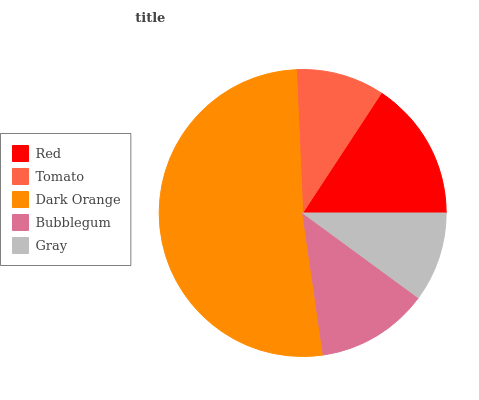Is Tomato the minimum?
Answer yes or no. Yes. Is Dark Orange the maximum?
Answer yes or no. Yes. Is Dark Orange the minimum?
Answer yes or no. No. Is Tomato the maximum?
Answer yes or no. No. Is Dark Orange greater than Tomato?
Answer yes or no. Yes. Is Tomato less than Dark Orange?
Answer yes or no. Yes. Is Tomato greater than Dark Orange?
Answer yes or no. No. Is Dark Orange less than Tomato?
Answer yes or no. No. Is Bubblegum the high median?
Answer yes or no. Yes. Is Bubblegum the low median?
Answer yes or no. Yes. Is Gray the high median?
Answer yes or no. No. Is Tomato the low median?
Answer yes or no. No. 